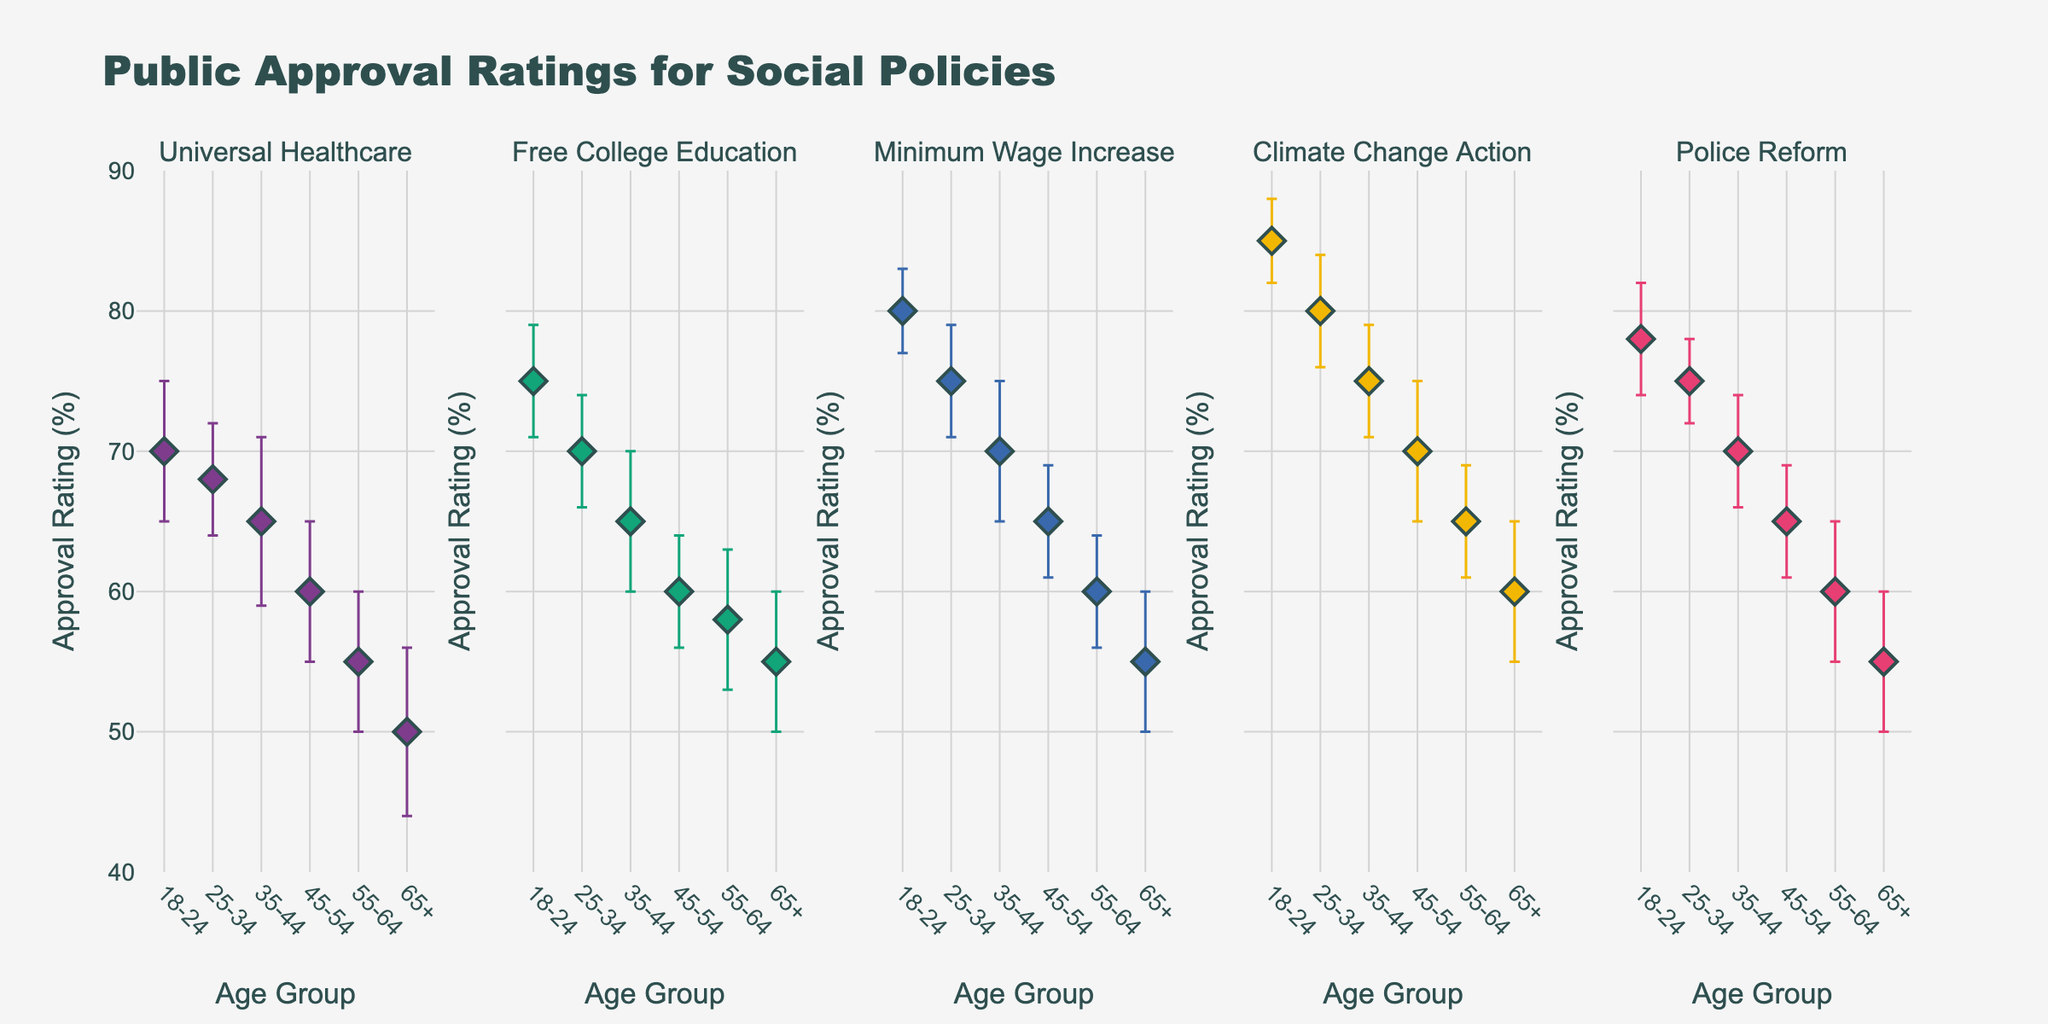What's the title of the figure? The title of the figure is usually located at the top center of the plot. It provides a summary of what the data visual represents.
Answer: Public Approval Ratings for Social Policies What is the approval rating for Climate Change Action among the 18-24 age group? To find this, locate the Climate Change Action subplot and look for the data point corresponding to the 18-24 age group. The y-axis value for this point gives the approval rating.
Answer: 85 Which policy has the highest approval rating among all age groups? Look across all subplots and identify the highest data point. This can be found in the Climate Change Action subplot for the 18-24 age group.
Answer: Climate Change Action How does the approval rating for Police Reform change across different age groups? To determine this, observe the trend in the Police Reform subplot. Notice how the approval rating decreases as the age group progresses from 18-24 to 65+ years.
Answer: The approval rating decreases as age increases Which age group has the smallest error margin for Universal Healthcare? To find the smallest error margin, examine the error bars in the Universal Healthcare subplot and identify the shortest error bar. This corresponds to the 25-34 age group.
Answer: 25-34 What's the difference in approval ratings for Free College Education between the 18-24 and 65+ age groups? Identify the approval ratings for Free College Education for the 18-24 and 65+ age groups, then subtract the latter from the former: 75 - 55.
Answer: 20 Comparing Universal Healthcare and Minimum Wage Increase, which policy has higher approval ratings among the 35-44 age group? Find and compare the approval ratings of these two policies in the respective subplots for the 35-44 age group. Universal Healthcare has a 65 rating, and Minimum Wage Increase has a 70 rating.
Answer: Minimum Wage Increase Which age group shows the most significant approval for all policies? Observe which age group consistently has the highest data points across all subplots. The 18-24 age group shows the most significant approval as it has the highest ratings for all policies.
Answer: 18-24 Is there any trend in approval ratings for Free College Education as age increases? To determine the trend, observe the Free College Education subplot and look at the approval ratings as they progress from the 18-24 age group to the 65+ age group. There is a decreasing trend.
Answer: The approval rating decreases as age increases What proportion of policies have approval ratings of 70 or higher among the 45-54 age group? Identify the approvals for the 45-54 age group in each subplot and count how many have ratings of 70 or higher. Only Climate Change Action has such a rating out of five policies.
Answer: 1 out of 5 (20%) 